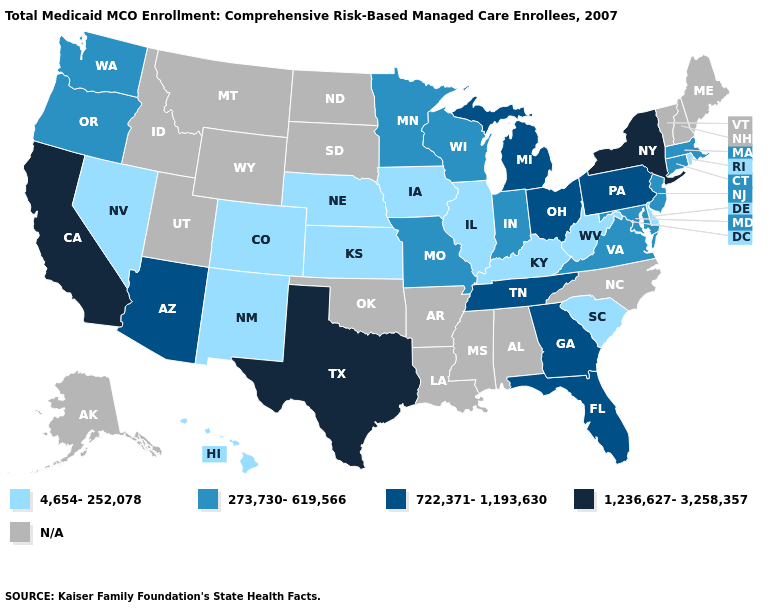Does Wisconsin have the highest value in the MidWest?
Keep it brief. No. What is the value of Virginia?
Give a very brief answer. 273,730-619,566. What is the value of Massachusetts?
Write a very short answer. 273,730-619,566. Which states hav the highest value in the Northeast?
Answer briefly. New York. Which states have the lowest value in the USA?
Give a very brief answer. Colorado, Delaware, Hawaii, Illinois, Iowa, Kansas, Kentucky, Nebraska, Nevada, New Mexico, Rhode Island, South Carolina, West Virginia. What is the lowest value in the USA?
Keep it brief. 4,654-252,078. How many symbols are there in the legend?
Quick response, please. 5. What is the value of Idaho?
Write a very short answer. N/A. Does Indiana have the lowest value in the MidWest?
Be succinct. No. What is the lowest value in states that border Oklahoma?
Answer briefly. 4,654-252,078. Name the states that have a value in the range 273,730-619,566?
Concise answer only. Connecticut, Indiana, Maryland, Massachusetts, Minnesota, Missouri, New Jersey, Oregon, Virginia, Washington, Wisconsin. What is the value of Massachusetts?
Be succinct. 273,730-619,566. What is the value of New York?
Quick response, please. 1,236,627-3,258,357. What is the value of California?
Short answer required. 1,236,627-3,258,357. How many symbols are there in the legend?
Write a very short answer. 5. 